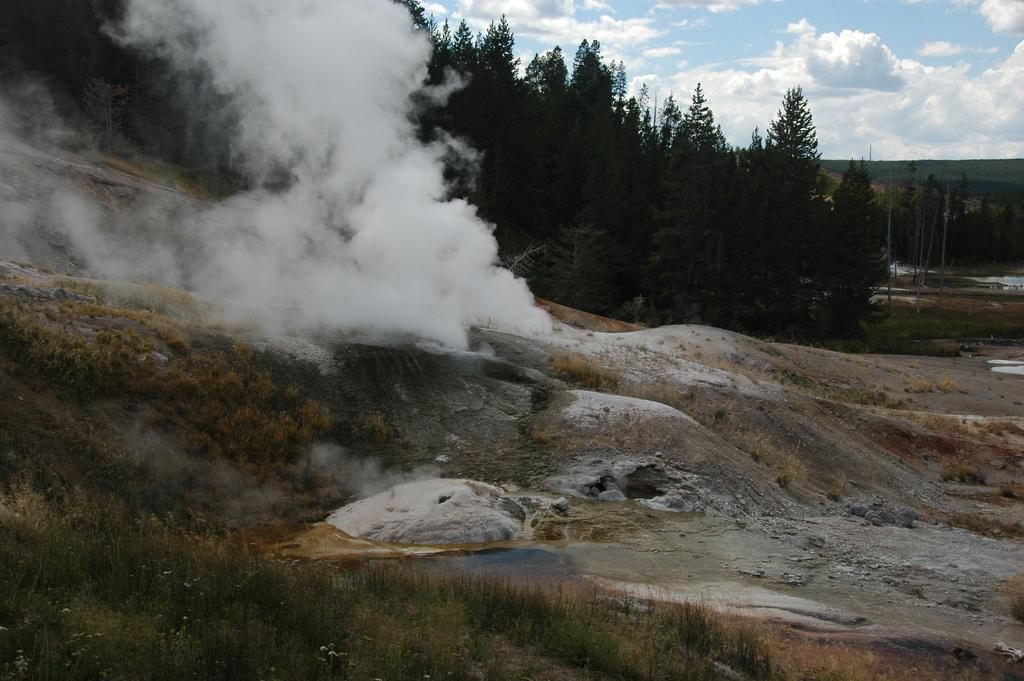Describe this image in one or two sentences. This image is taken outdoors. At the top of the image there is the sky with clouds. At the bottom of the image there is a ground with grass on it and there are a few stones on the ground. In the background there are many trees and plants on the ground. In the middle of the image there is smoke. 